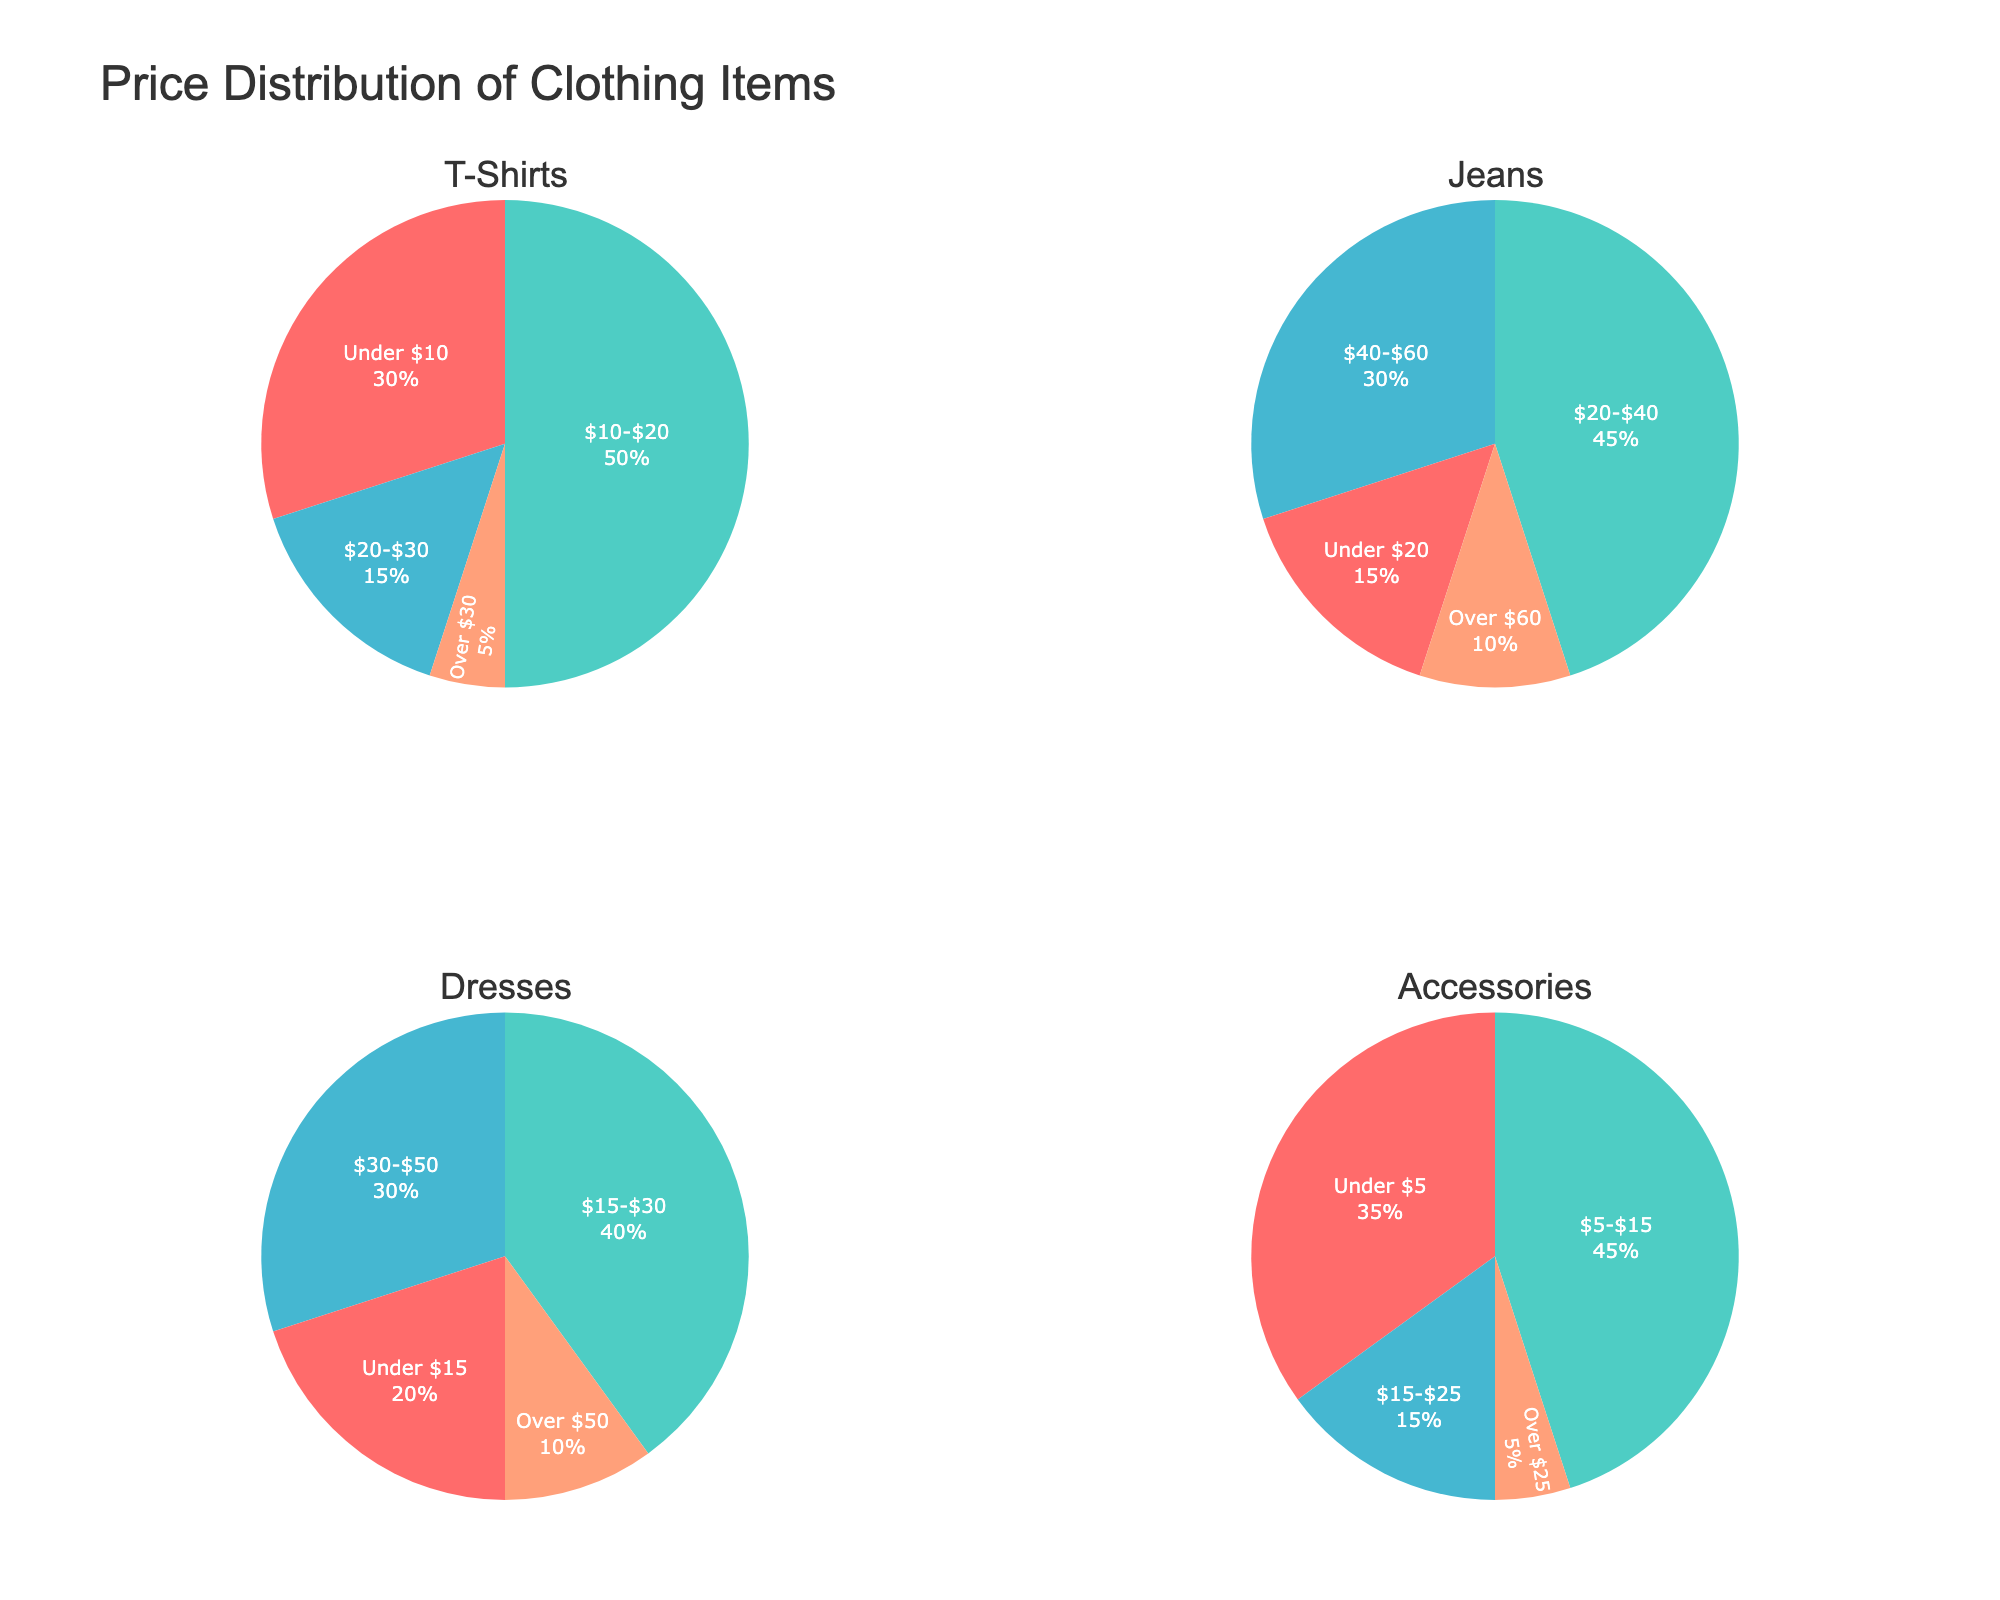What’s the title of the figure? The title is located at the top center of the figure. It reads "Comparison of Artificial Life Simulation Platforms."
Answer: Comparison of Artificial Life Simulation Platforms Which platform consumes the most energy? To find the platform with the highest energy consumption, look at the y-axis of the left subplot (Energy Consumption vs. Platform) and find the highest data point. It corresponds to "Polyworld," consuming 150 kWh.
Answer: Polyworld What's the minimum computational efficiency (FLOPS) observed in the figure? Look at the y-axis of the right subplot (Computational Efficiency vs. Platform) and identify the lowest plotted data point. The minimum value is associated with "Geb," approximately 3.2e12 FLOPS.
Answer: 3.2e12 Which platforms have both energy consumption and computational efficiency values below the middle range of the observed data? To find these platforms, identify points on both subplots below the middle range of their respective axes. "Tierra," "Geb," and "Darwinbots" qualify as their consumption is below ~110 kWh and efficiency is below ~4.9e12 FLOPS.
Answer: Tierra, Geb, Darwinbots Is there a strong correlation between energy consumption and computational efficiency across platforms? Check if higher energy consumption data points correspond to higher computational efficiencies by comparing the positions of data points in both subplots. The pattern shows inconsistent correlation; some high energy-using platforms have similar or lower efficiency compared to less energy-consuming platforms.
Answer: No Which platform has the closest energy consumption to 100 kWh? On the left subplot, locate the data point near 100 kWh on the y-axis. "StringMOL" is the platform nearest to this value.
Answer: StringMOL How many platforms have an energy consumption value above 120 kWh? Count the data points above 120 kWh on the y-axis of the left subplot. There are three such platforms: "Polyworld," "Aevol," and "EcoSim."
Answer: Three What is the difference in computational efficiency between the highest and lowest platforms? Identify the highest (Polyworld at 6.5e12 FLOPS) and the lowest (Geb at 3.2e12 FLOPS) computational efficiency values from the right subplot. Subtract the lowest from the highest: 6.5e12 - 3.2e12 = 3.3e12 FLOPS.
Answer: 3.3e12 List platforms with energy consumption between 100 and 130 kWh and their corresponding efficiencies. Look at the left subplot for data points between 100 and 130 kWh, then cross-check with the right subplot for their corresponding efficiencies. Platforms: "StringMOL" (4.5e12 FLOPS), "Primordial Life" (4.7e12 FLOPS), "Evita" (5.0e12 FLOPS), "Avida" (5.2e12 FLOPS), and "Aevol" (6.1e12 FLOPS).
Answer: StringMOL, Primordial Life, Evita, Avida, Aevol Which platform has the highest energy consumption while having computational efficiency below 4.0e12 FLOPS? Look at platforms with data points below 4.0e12 FLOPS in the right subplot, then identify the one with the highest value on the left subplot. "Tierra" consumes 85 kWh and has efficiency of 3.8e12 FLOPS.
Answer: Tierra 